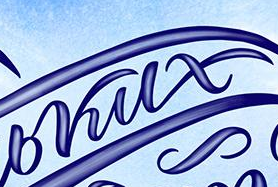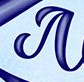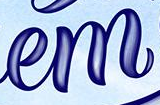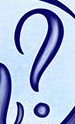What words are shown in these images in order, separated by a semicolon? bkux; #; em; ? 